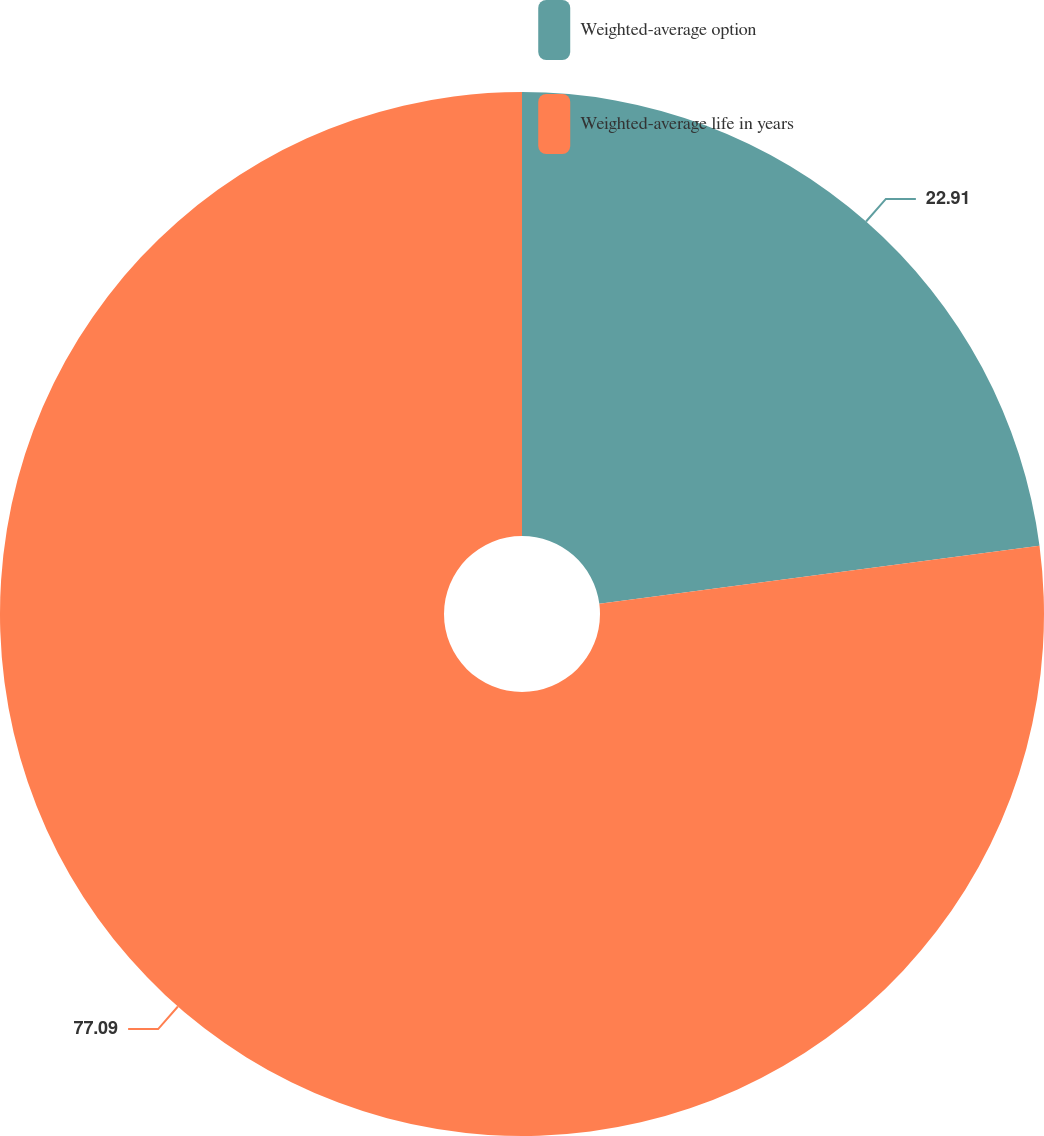<chart> <loc_0><loc_0><loc_500><loc_500><pie_chart><fcel>Weighted-average option<fcel>Weighted-average life in years<nl><fcel>22.91%<fcel>77.09%<nl></chart> 